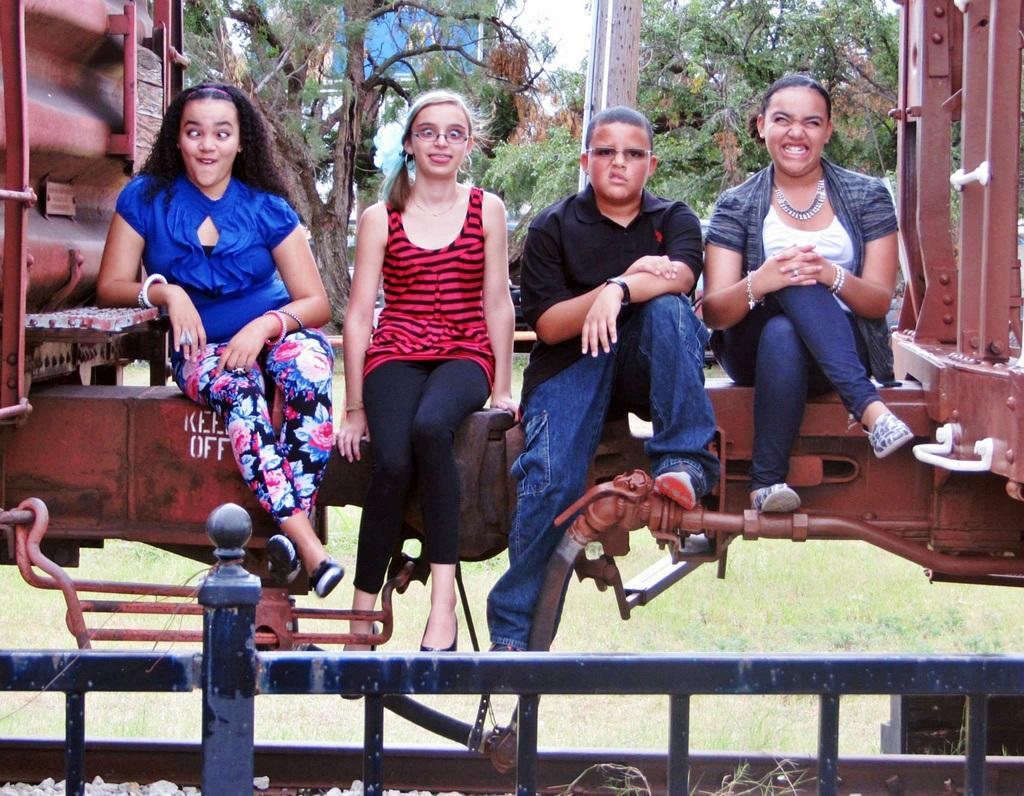Please provide a concise description of this image. In this image I can see the four people sitting on the parts of the train. These people are wearing the different color dresses and one person with the specs. In-front of these people there is a railing. In the background there are many trees and the sky. 